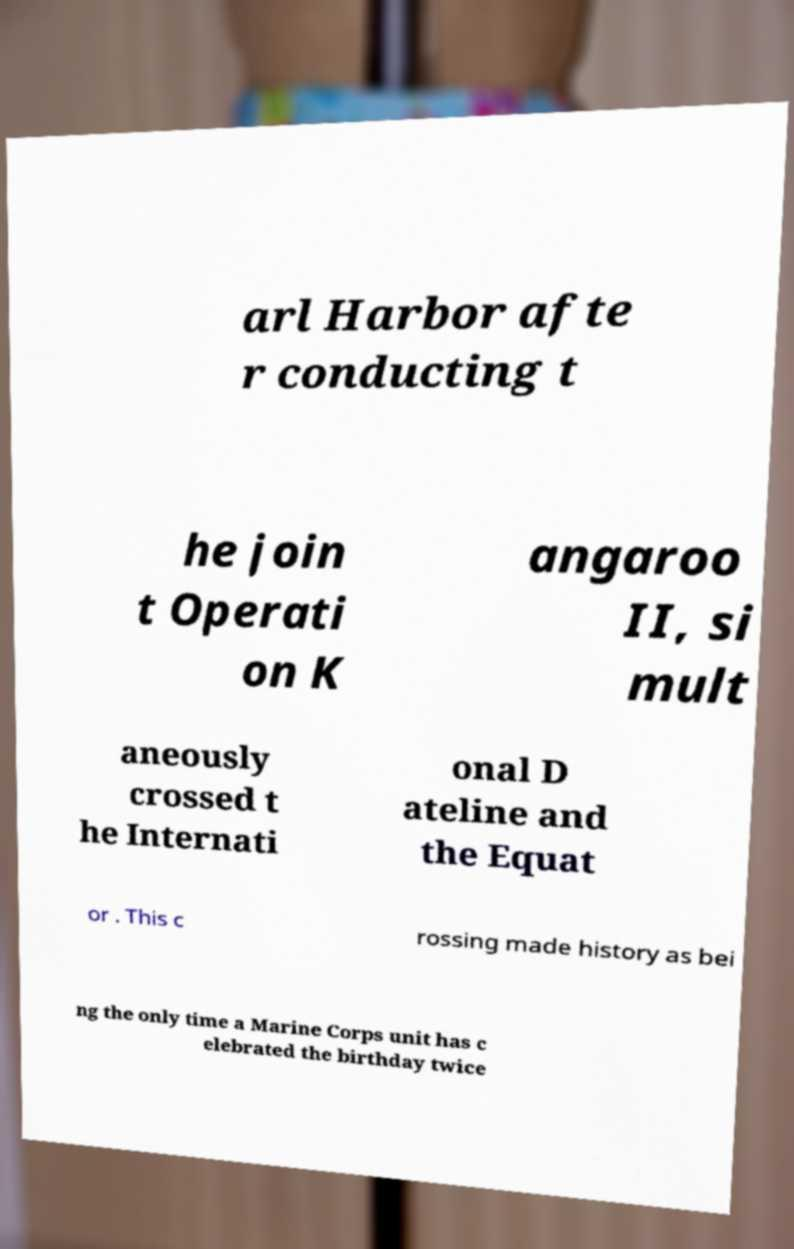Can you accurately transcribe the text from the provided image for me? arl Harbor afte r conducting t he join t Operati on K angaroo II, si mult aneously crossed t he Internati onal D ateline and the Equat or . This c rossing made history as bei ng the only time a Marine Corps unit has c elebrated the birthday twice 